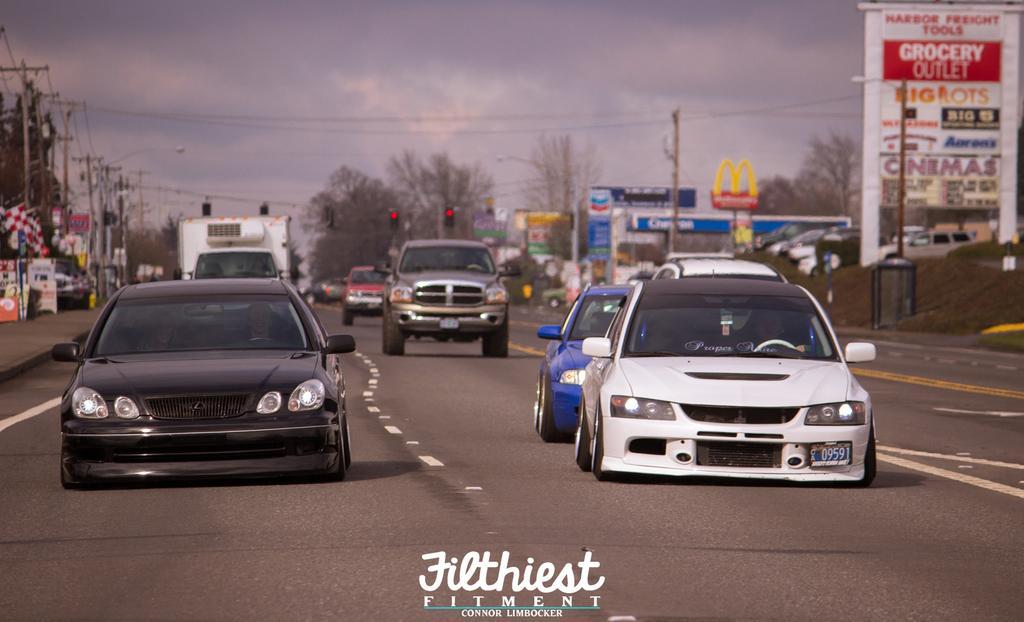<image>
Summarize the visual content of the image. A photo of couple of low rider cars that says Filthiest Fitment under it. 